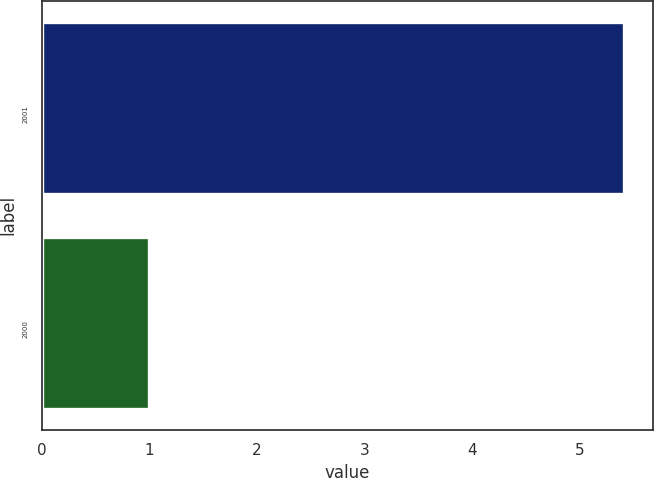Convert chart to OTSL. <chart><loc_0><loc_0><loc_500><loc_500><bar_chart><fcel>2001<fcel>2000<nl><fcel>5.41<fcel>1<nl></chart> 